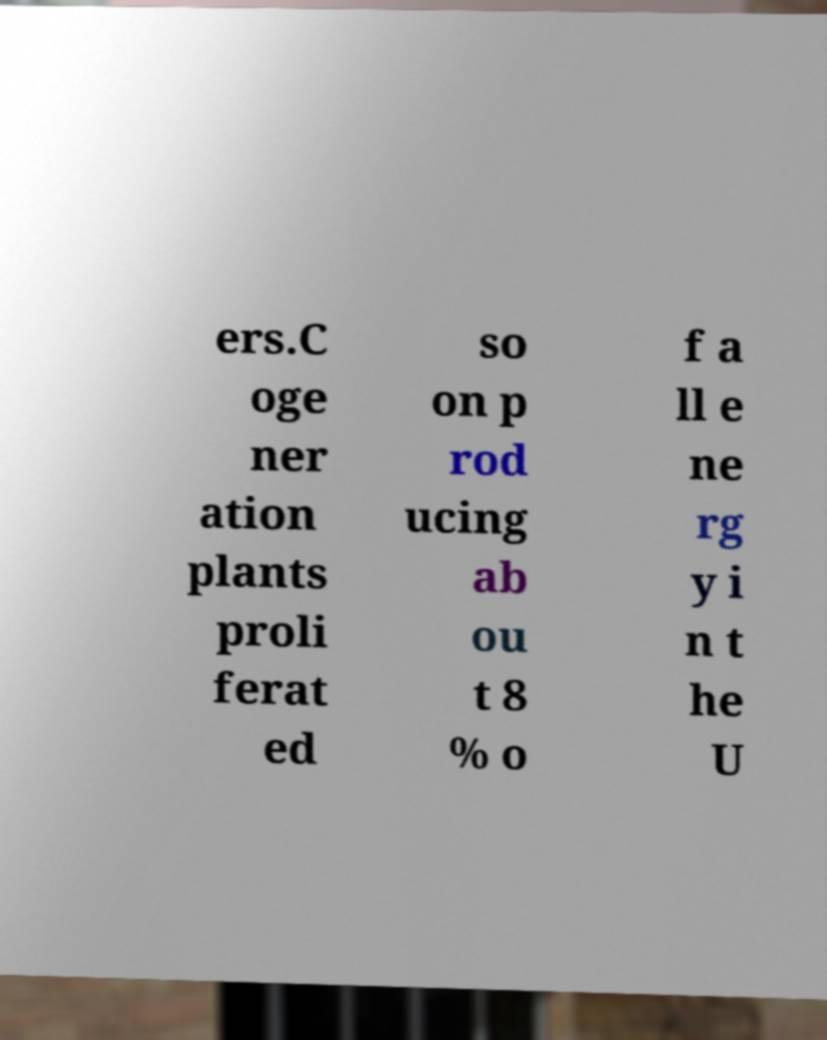Can you read and provide the text displayed in the image?This photo seems to have some interesting text. Can you extract and type it out for me? ers.C oge ner ation plants proli ferat ed so on p rod ucing ab ou t 8 % o f a ll e ne rg y i n t he U 